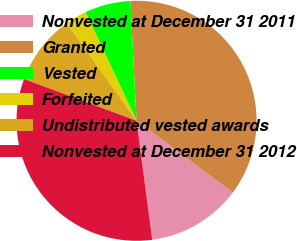Convert chart to OTSL. <chart><loc_0><loc_0><loc_500><loc_500><pie_chart><fcel>Nonvested at December 31 2011<fcel>Granted<fcel>Vested<fcel>Forfeited<fcel>Undistributed vested awards<fcel>Nonvested at December 31 2012<nl><fcel>12.72%<fcel>36.01%<fcel>6.18%<fcel>2.9%<fcel>9.45%<fcel>32.74%<nl></chart> 